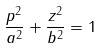Convert formula to latex. <formula><loc_0><loc_0><loc_500><loc_500>\frac { p ^ { 2 } } { a ^ { 2 } } + \frac { z ^ { 2 } } { b ^ { 2 } } = 1</formula> 